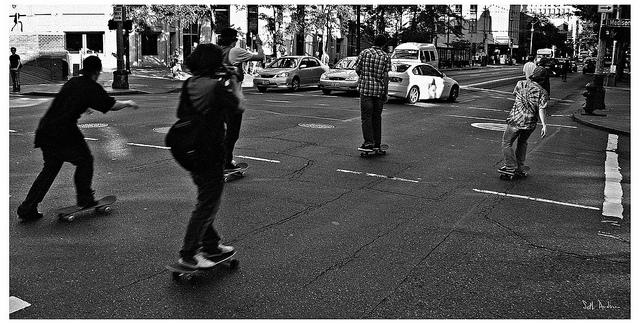What type of shirt is the man on the right wearing? Please explain your reasoning. tie dye. One can see the telltale markings of the dip dye technique. 